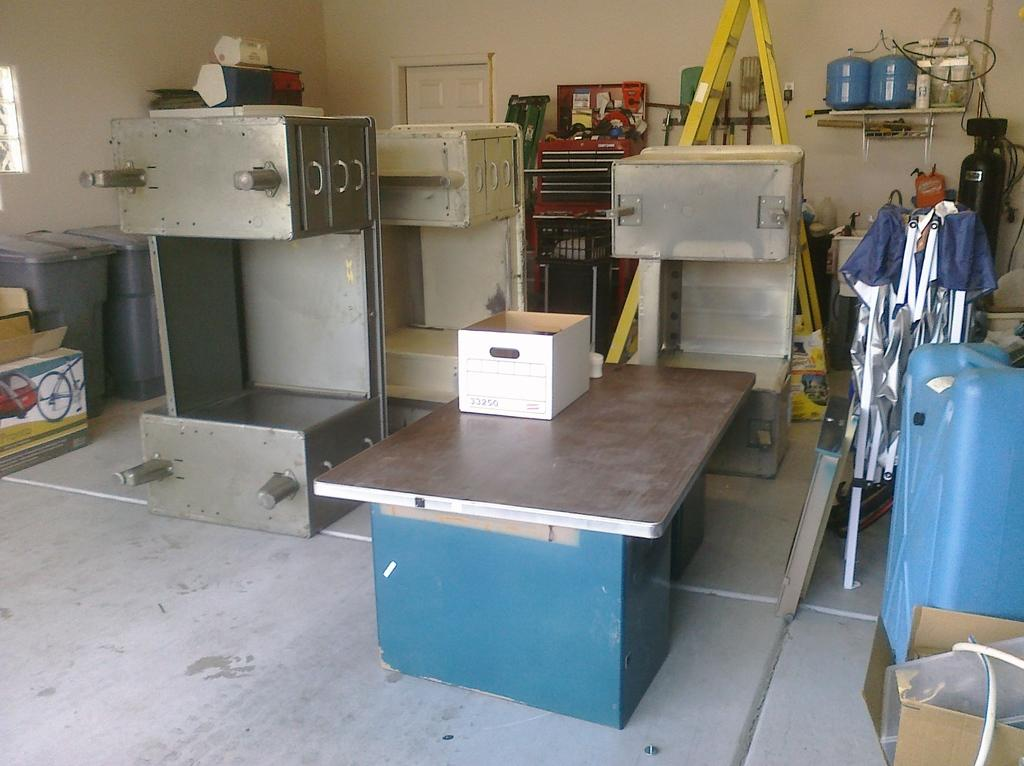What is covering the floor in the image? There is a sheet in the image. What is placed on the sheet? There is a box on the sheet. What type of surface is visible in the image? The image shows a floor. What items are used for waste disposal in the image? Dustbins are present in the image. What other objects can be seen in the image? There are other objects in the image, but their specific details are not mentioned in the facts. What can be seen through the window in the image? The facts do not mention what can be seen through the window. What type of structure is visible in the image? There is a wall in the image. What is the plot of the story being told in the image? The image does not depict a story or plot; it is a still image of a sheet, box, floor, dustbins, and other objects. How much wealth is represented by the objects in the image? The image does not convey any information about the wealth or value of the objects depicted. 